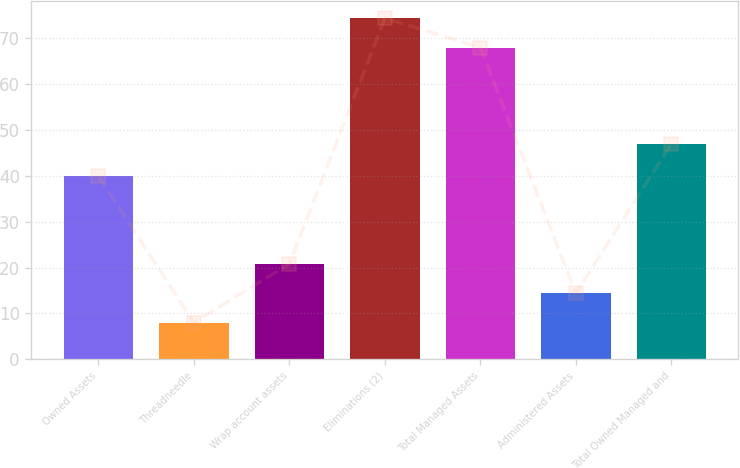<chart> <loc_0><loc_0><loc_500><loc_500><bar_chart><fcel>Owned Assets<fcel>Threadneedle<fcel>Wrap account assets<fcel>Eliminations (2)<fcel>Total Managed Assets<fcel>Administered Assets<fcel>Total Owned Managed and<nl><fcel>40<fcel>8<fcel>20.8<fcel>74.4<fcel>68<fcel>14.4<fcel>47<nl></chart> 